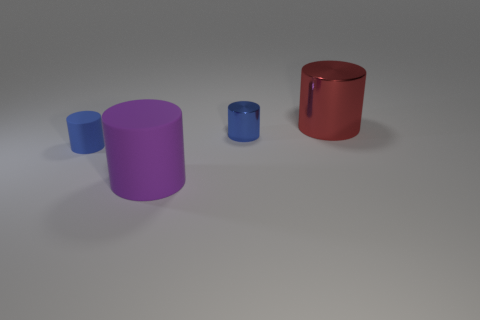What size is the matte cylinder that is on the right side of the thing to the left of the large cylinder in front of the big red thing?
Keep it short and to the point. Large. How many tiny blue cylinders are made of the same material as the large purple object?
Your answer should be compact. 1. Is the number of purple rubber things less than the number of green things?
Your response must be concise. No. What size is the blue matte object that is the same shape as the tiny shiny object?
Ensure brevity in your answer.  Small. Does the blue cylinder that is on the left side of the small blue metallic cylinder have the same material as the big purple thing?
Offer a very short reply. Yes. Does the purple object have the same shape as the red thing?
Ensure brevity in your answer.  Yes. What number of things are either large objects that are to the right of the tiny metal thing or tiny blue things?
Offer a terse response. 3. What size is the other thing that is the same material as the purple object?
Provide a succinct answer. Small. How many tiny matte objects are the same color as the big metal thing?
Provide a succinct answer. 0. What number of large things are green rubber cylinders or blue shiny cylinders?
Offer a terse response. 0. 